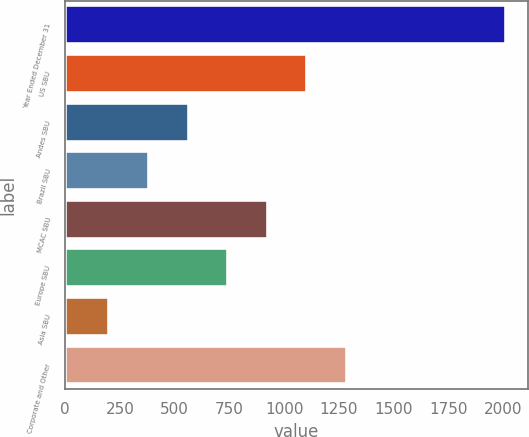<chart> <loc_0><loc_0><loc_500><loc_500><bar_chart><fcel>Year Ended December 31<fcel>US SBU<fcel>Andes SBU<fcel>Brazil SBU<fcel>MCAC SBU<fcel>Europe SBU<fcel>Asia SBU<fcel>Corporate and Other<nl><fcel>2012<fcel>1106.5<fcel>563.2<fcel>382.1<fcel>925.4<fcel>744.3<fcel>201<fcel>1287.6<nl></chart> 